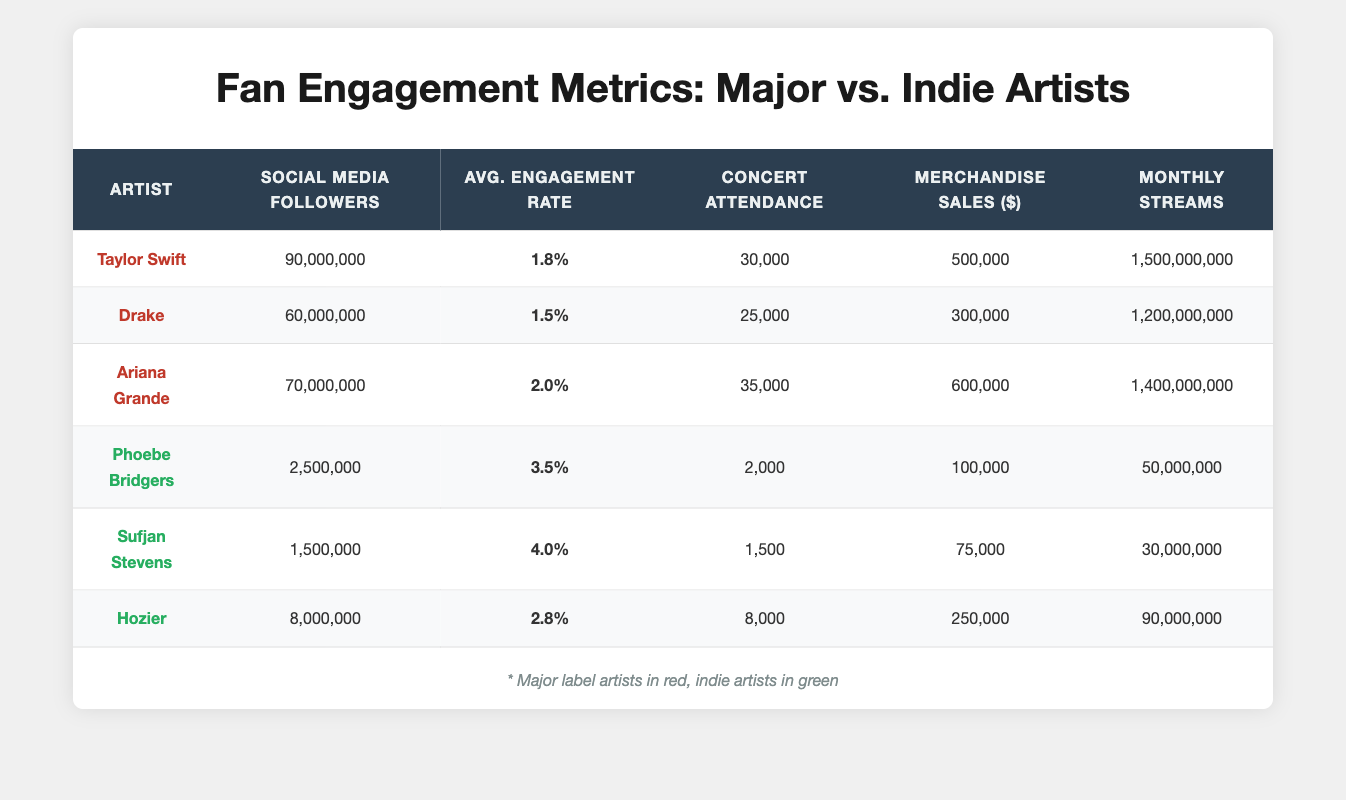What is the concert attendance of Taylor Swift? Taylor Swift's concert attendance is listed in the table under the "Concert Attendance" column, where her value is 30,000.
Answer: 30,000 Which indie artist has the highest average engagement rate? By comparing the "Average Engagement Rate" values for the indie artists, Phoebe Bridgers has 3.5%, Sufjan Stevens has 4.0%, and Hozier has 2.8%. The highest among these is Sufjan Stevens with 4.0%.
Answer: Sufjan Stevens How much are the total merchandise sales for all major label artists combined? The merchandise sales for major label artists are Taylor Swift (500,000) + Drake (300,000) + Ariana Grande (600,000), which sums up to 1,400,000.
Answer: 1,400,000 Is the average engagement rate of indie artists higher than that of major label artists? To answer this, we can calculate the average engagement rate for both groups. Major label artists have average rates of 1.8, 1.5, and 2.0, totaling 5.3 for three artists (5.3/3 = 1.77). Indie artists have rates of 3.5, 4.0, and 2.8, totaling 10.3 for three artists (10.3/3 = 3.43). Since 3.43 > 1.77, the statement holds true.
Answer: Yes What is the difference in social media followers between Arian Grande and Hozier? Ariana Grande has 70,000,000 social media followers, while Hozier has 8,000,000. The difference is 70,000,000 - 8,000,000 = 62,000,000.
Answer: 62,000,000 Do any indie artists have more concert attendance than Taylor Swift? Taylor Swift's concert attendance is 30,000. The indie artists have attendance values of 2,000 (Phoebe Bridgers), 1,500 (Sufjan Stevens), and 8,000 (Hozier). All of these values are less than 30,000, indicating that no indie artist surpasses her attendance.
Answer: No 